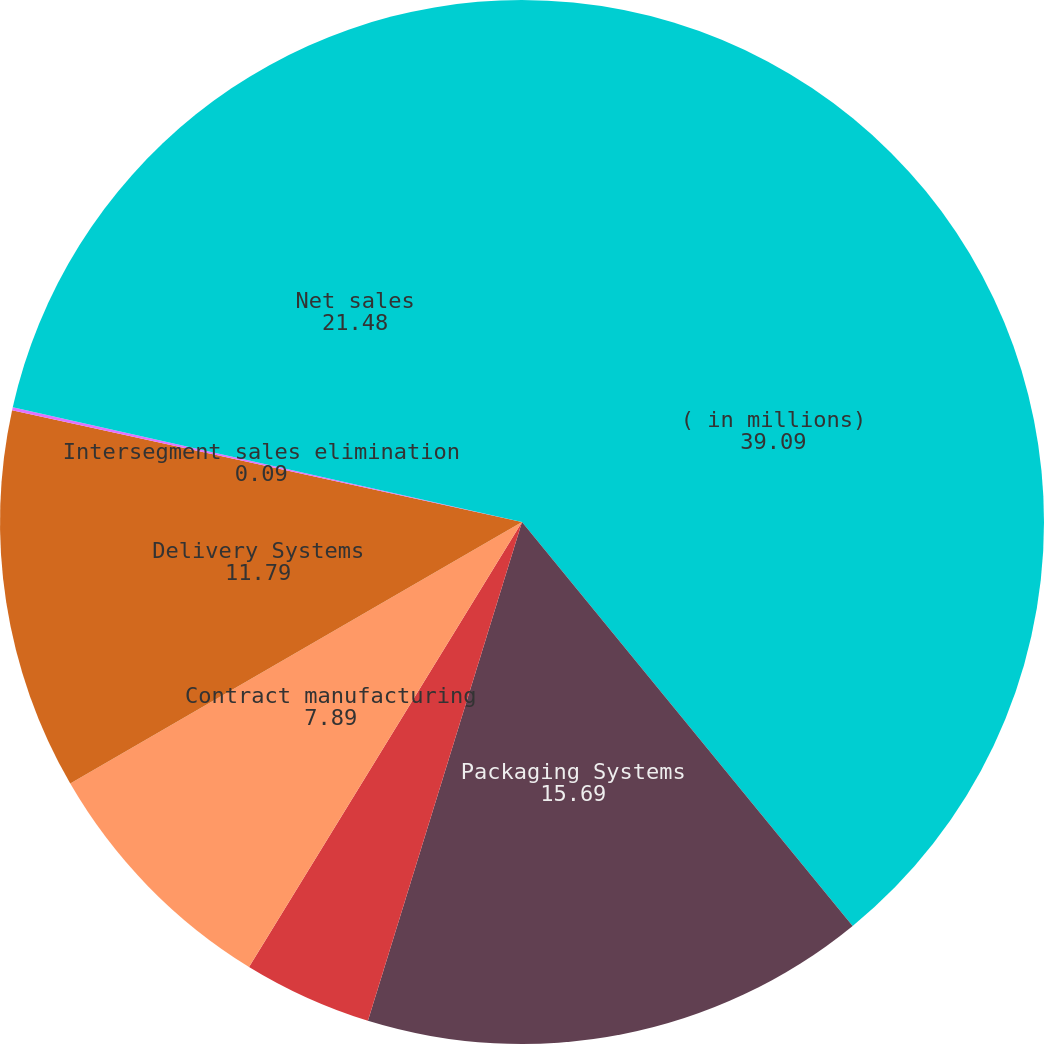Convert chart. <chart><loc_0><loc_0><loc_500><loc_500><pie_chart><fcel>( in millions)<fcel>Packaging Systems<fcel>Proprietary products<fcel>Contract manufacturing<fcel>Delivery Systems<fcel>Intersegment sales elimination<fcel>Net sales<nl><fcel>39.09%<fcel>15.69%<fcel>3.99%<fcel>7.89%<fcel>11.79%<fcel>0.09%<fcel>21.48%<nl></chart> 